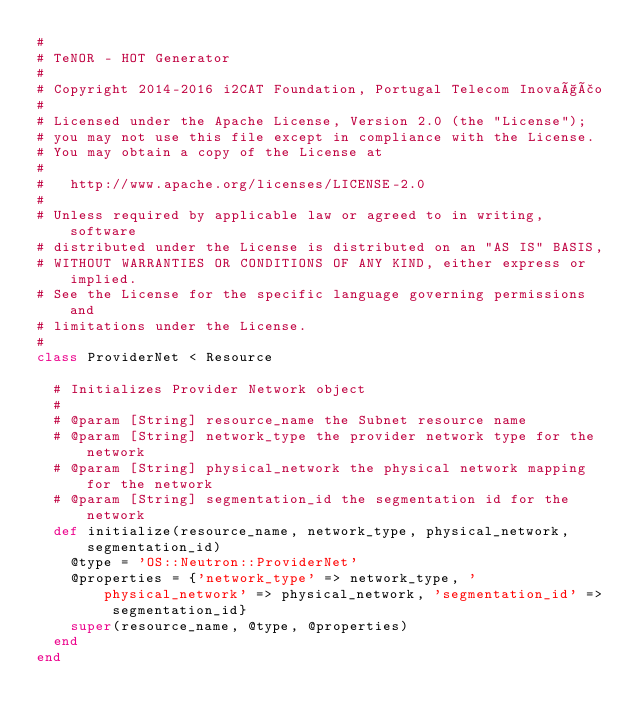<code> <loc_0><loc_0><loc_500><loc_500><_Ruby_>#
# TeNOR - HOT Generator
#
# Copyright 2014-2016 i2CAT Foundation, Portugal Telecom Inovação
#
# Licensed under the Apache License, Version 2.0 (the "License");
# you may not use this file except in compliance with the License.
# You may obtain a copy of the License at
#
#   http://www.apache.org/licenses/LICENSE-2.0
#
# Unless required by applicable law or agreed to in writing, software
# distributed under the License is distributed on an "AS IS" BASIS,
# WITHOUT WARRANTIES OR CONDITIONS OF ANY KIND, either express or implied.
# See the License for the specific language governing permissions and
# limitations under the License.
#
class ProviderNet < Resource

  # Initializes Provider Network object
  #
  # @param [String] resource_name the Subnet resource name
  # @param [String] network_type the provider network type for the network
  # @param [String] physical_network the physical network mapping for the network
  # @param [String] segmentation_id the segmentation id for the network
  def initialize(resource_name, network_type, physical_network, segmentation_id)
    @type = 'OS::Neutron::ProviderNet'
    @properties = {'network_type' => network_type, 'physical_network' => physical_network, 'segmentation_id' => segmentation_id}
    super(resource_name, @type, @properties)
  end
end</code> 